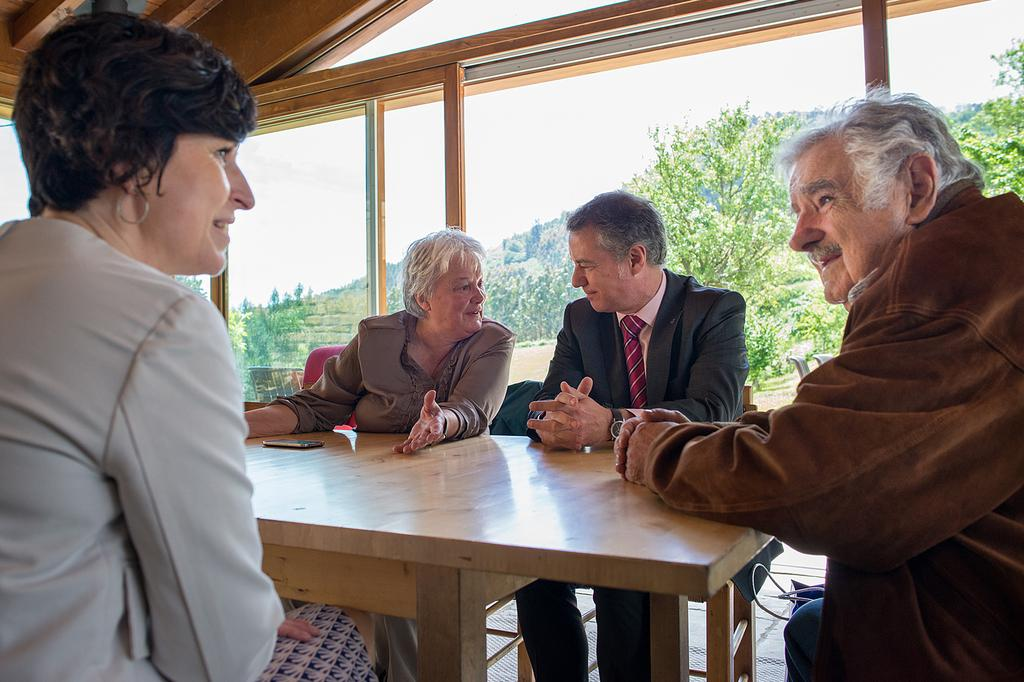How many people are in the image? There are 2 men and 2 women in the image, making a total of 4 people. What are the people doing in the image? The people are sitting in the image. What is in front of the people? There is a table in front of the people. What can be seen through the glass in the background of the image? Trees are visible through the glass in the background of the image. What type of dinosaurs can be seen in the middle of the image? There are no dinosaurs present in the image; it features 4 people sitting around a table. What year is depicted in the image? The image does not depict a specific year; it is a snapshot of a moment in time. 